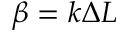<formula> <loc_0><loc_0><loc_500><loc_500>\beta = k \Delta L</formula> 